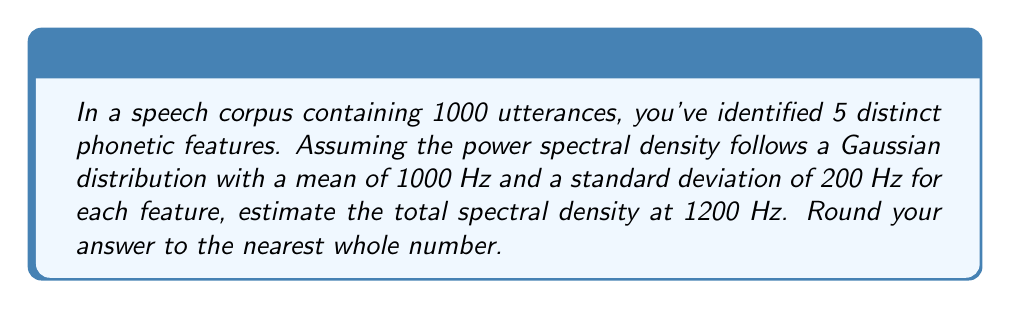What is the answer to this math problem? Let's approach this step-by-step:

1) The power spectral density for each feature follows a Gaussian distribution:

   $$S(f) = \frac{1}{\sigma\sqrt{2\pi}} e^{-\frac{(f-\mu)^2}{2\sigma^2}}$$

   where $\mu = 1000$ Hz and $\sigma = 200$ Hz.

2) We need to calculate this for $f = 1200$ Hz:

   $$S(1200) = \frac{1}{200\sqrt{2\pi}} e^{-\frac{(1200-1000)^2}{2(200)^2}}$$

3) Let's solve the exponent first:

   $$\frac{(1200-1000)^2}{2(200)^2} = \frac{200^2}{2(200)^2} = \frac{1}{2}$$

4) Now our equation looks like:

   $$S(1200) = \frac{1}{200\sqrt{2\pi}} e^{-\frac{1}{2}}$$

5) Calculating this:

   $$S(1200) \approx 0.001497$$

6) Since we have 5 distinct phonetic features, and assuming they are independent, we multiply this value by 5:

   $$5 * 0.001497 = 0.007485$$

7) Rounding to the nearest whole number:

   $$0.007485 \approx 0$$
Answer: 0 